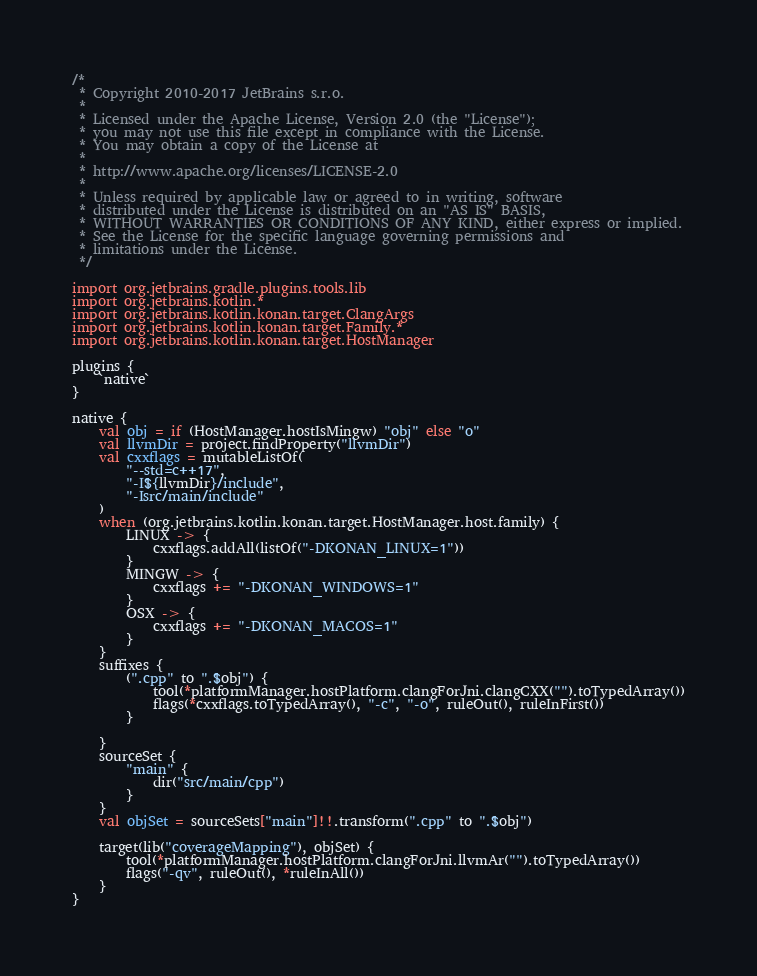Convert code to text. <code><loc_0><loc_0><loc_500><loc_500><_Kotlin_>/*
 * Copyright 2010-2017 JetBrains s.r.o.
 *
 * Licensed under the Apache License, Version 2.0 (the "License");
 * you may not use this file except in compliance with the License.
 * You may obtain a copy of the License at
 *
 * http://www.apache.org/licenses/LICENSE-2.0
 *
 * Unless required by applicable law or agreed to in writing, software
 * distributed under the License is distributed on an "AS IS" BASIS,
 * WITHOUT WARRANTIES OR CONDITIONS OF ANY KIND, either express or implied.
 * See the License for the specific language governing permissions and
 * limitations under the License.
 */

import org.jetbrains.gradle.plugins.tools.lib
import org.jetbrains.kotlin.*
import org.jetbrains.kotlin.konan.target.ClangArgs
import org.jetbrains.kotlin.konan.target.Family.*
import org.jetbrains.kotlin.konan.target.HostManager

plugins {
    `native`
}

native {
    val obj = if (HostManager.hostIsMingw) "obj" else "o"
    val llvmDir = project.findProperty("llvmDir")
    val cxxflags = mutableListOf(
        "--std=c++17",
        "-I${llvmDir}/include",
        "-Isrc/main/include"
    )
    when (org.jetbrains.kotlin.konan.target.HostManager.host.family) {
        LINUX -> {
            cxxflags.addAll(listOf("-DKONAN_LINUX=1"))
        }
        MINGW -> {
            cxxflags += "-DKONAN_WINDOWS=1"
        }
        OSX -> {
            cxxflags += "-DKONAN_MACOS=1"
        }
    }
    suffixes {
        (".cpp" to ".$obj") {
            tool(*platformManager.hostPlatform.clangForJni.clangCXX("").toTypedArray())
            flags(*cxxflags.toTypedArray(), "-c", "-o", ruleOut(), ruleInFirst())
        }

    }
    sourceSet {
        "main" {
            dir("src/main/cpp")
        }
    }
    val objSet = sourceSets["main"]!!.transform(".cpp" to ".$obj")

    target(lib("coverageMapping"), objSet) {
        tool(*platformManager.hostPlatform.clangForJni.llvmAr("").toTypedArray())
        flags("-qv", ruleOut(), *ruleInAll())
    }
}
</code> 